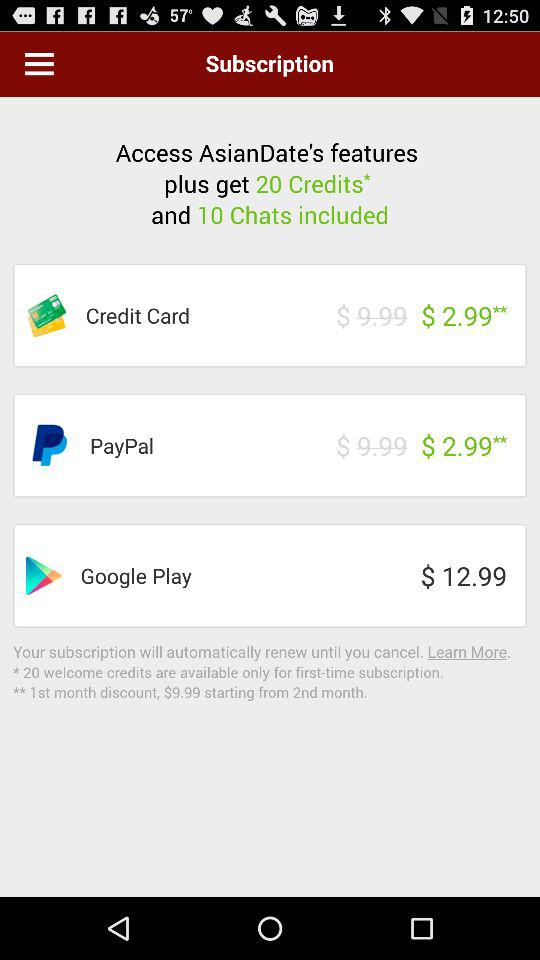What is the subscription price for Google Play? The subscription price for Google Play is $12.99. 